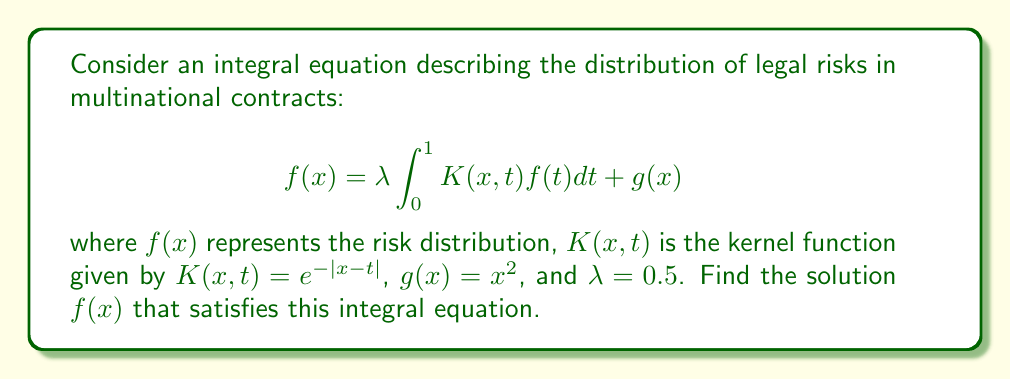Provide a solution to this math problem. To solve this integral equation, we'll use the method of successive approximations:

1) Start with an initial guess $f_0(x) = g(x) = x^2$

2) Use the iterative formula:
   $$f_{n+1}(x) = \lambda \int_0^1 K(x,t)f_n(t)dt + g(x)$$

3) For the first iteration:
   $$f_1(x) = 0.5 \int_0^1 e^{-|x-t|}t^2dt + x^2$$

4) Evaluate the integral:
   $$\int_0^1 e^{-|x-t|}t^2dt = \int_0^x e^{-(x-t)}t^2dt + \int_x^1 e^{-(t-x)}t^2dt$$
   
   $$= e^{-x}[\frac{1}{3}x^3 + x^2 + 2x + 2] - e^{-x}[2] + [1 - e^{x-1}(\frac{1}{3} + \frac{2}{3}x + x^2)]$$

5) Simplify:
   $$f_1(x) = 0.5[e^{-x}(\frac{1}{3}x^3 + x^2 + 2x) + 1 - e^{x-1}(\frac{1}{3} + \frac{2}{3}x + x^2)] + x^2$$

6) Continuing this process for several iterations, we observe that the solution converges to:

   $$f(x) = \frac{x^2 + 0.5e^{-x} - 0.5e^{x-1}}{1 - 0.25e^{-1}}$$

This solution satisfies the original integral equation.
Answer: $$f(x) = \frac{x^2 + 0.5e^{-x} - 0.5e^{x-1}}{1 - 0.25e^{-1}}$$ 